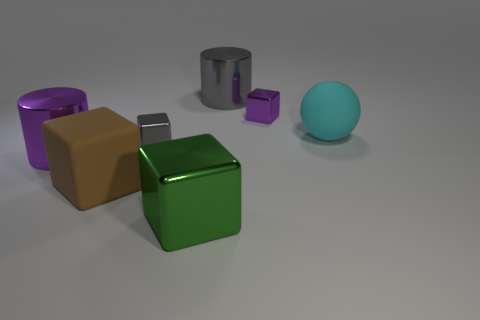There is a large cylinder in front of the small shiny thing right of the large gray cylinder; what color is it? purple 